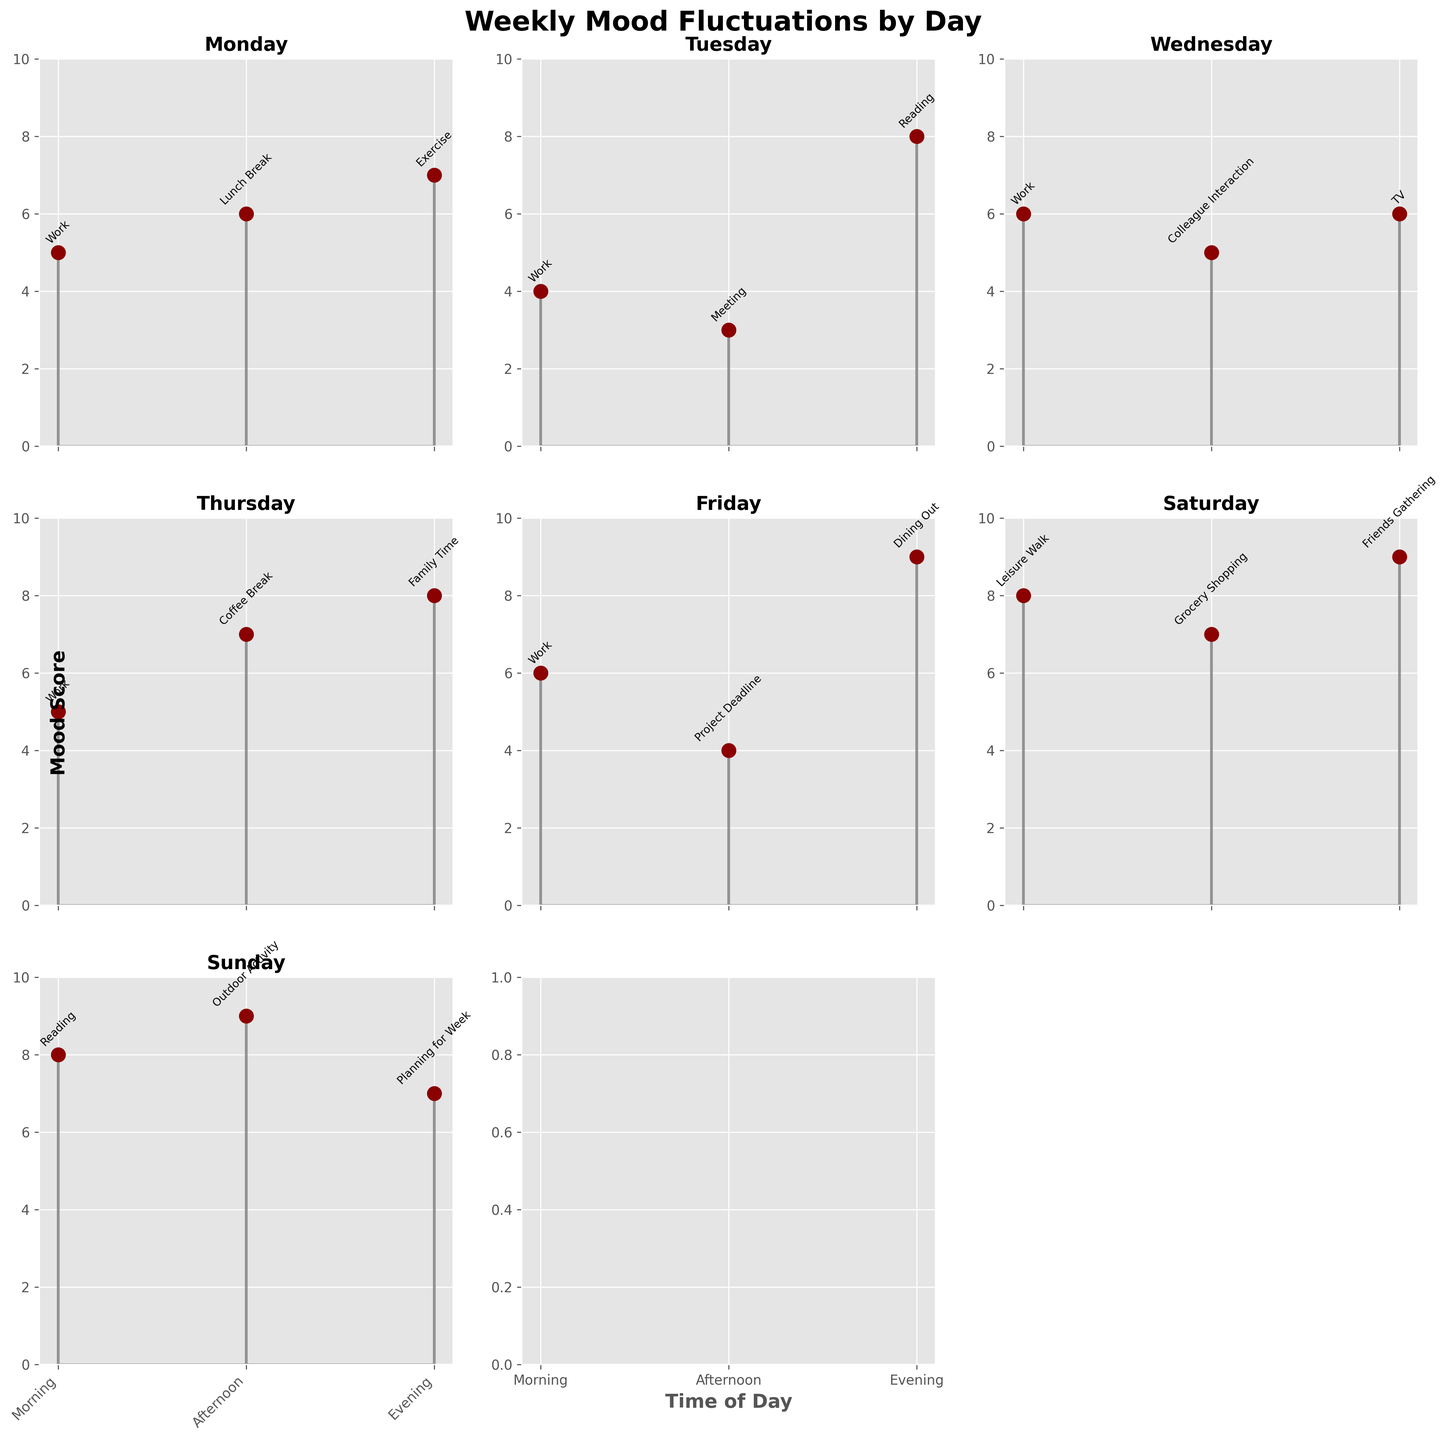How many days are covered by the figure? The title "Weekly Mood Fluctuations by Day" suggests it covers a week, and the subplots are titled with days of the week from Monday to Sunday.
Answer: 7 What is the average mood score on Monday? The mood scores for Monday are 5, 6, and 7. Summing these (5 + 6 + 7 = 18) and dividing by the number of scores (3) gives an average of 18 / 3.
Answer: 6 Which day has the highest average mood score? Calculate the average mood score for each day. The day with the highest average will be the answer:
Monday: (5+6+7)/3 = 6
Tuesday: (4+3+8)/3 = 5
Wednesday: (6+5+6)/3 = 5.67
Thursday: (5+7+8)/3 = 6.67
Friday: (6+4+9)/3 = 6.33
Saturday: (8+7+9)/3 = 8
Sunday: (8+9+7)/3 = 8
Saturday and Sunday both have the highest average mood score of 8.
Answer: Saturday and Sunday On which day was the mood score at the highest value? By inspecting each subplot, the highest mood score (9) appears twice: on Friday evening and Saturday evening and Sunday afternoon.
Answer: Friday, Saturday and Sunday Which activity has the lowest mood score? Identify the activities with their corresponding mood scores:
Work (Monday): 5
Work (Tuesday): 4
Meeting (Tuesday): 3
Reading (Tuesday): 8 
...
The meeting on Tuesday has the lowest mood score of 3.
Answer: Meeting What is the mood score difference between Tuesday morning and Tuesday evening? The mood score for Tuesday morning (Work) is 4, and the mood score for Tuesday evening (Reading) is 8. The difference is 8 - 4.
Answer: 4 How many activities scored a 9 in mood score? By checking through the subplots, there are three activities with a mood score of 9: Dining Out (Friday evening), Friends Gathering (Saturday evening), and Outdoor Activity (Sunday afternoon).
Answer: 3 Are morning mood scores higher or lower on average compared to evening mood scores? Calculate averages:
Morning: (5+4+6+5+6+8+8)/7 = 6
Evening: (7+8+6+8+9+9+7)/7 = 7.71
Evening scores are higher on average.
Answer: Higher 